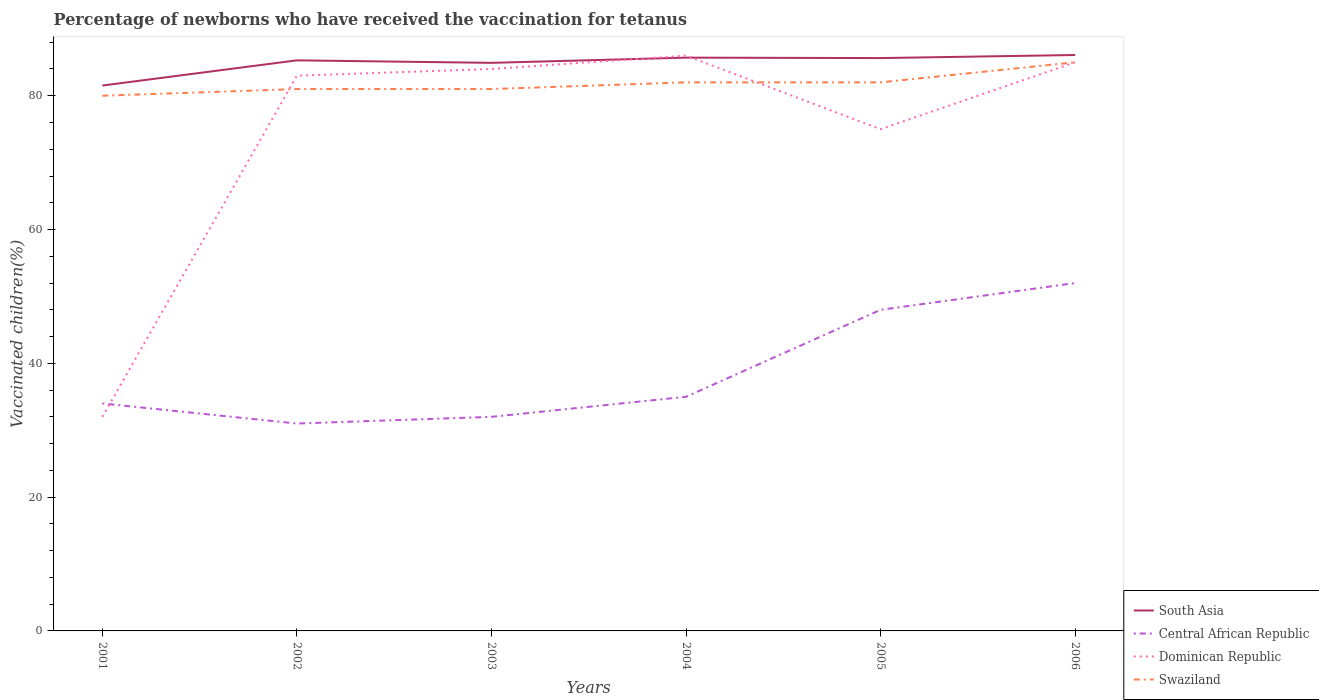How many different coloured lines are there?
Your response must be concise. 4. Does the line corresponding to South Asia intersect with the line corresponding to Dominican Republic?
Your answer should be compact. Yes. Across all years, what is the maximum percentage of vaccinated children in Dominican Republic?
Provide a succinct answer. 32. What is the total percentage of vaccinated children in Dominican Republic in the graph?
Offer a terse response. -53. What is the difference between the highest and the second highest percentage of vaccinated children in South Asia?
Ensure brevity in your answer.  4.57. Are the values on the major ticks of Y-axis written in scientific E-notation?
Your answer should be very brief. No. Where does the legend appear in the graph?
Keep it short and to the point. Bottom right. How many legend labels are there?
Give a very brief answer. 4. What is the title of the graph?
Provide a short and direct response. Percentage of newborns who have received the vaccination for tetanus. What is the label or title of the Y-axis?
Your response must be concise. Vaccinated children(%). What is the Vaccinated children(%) of South Asia in 2001?
Your answer should be compact. 81.52. What is the Vaccinated children(%) in Central African Republic in 2001?
Provide a succinct answer. 34. What is the Vaccinated children(%) of Dominican Republic in 2001?
Make the answer very short. 32. What is the Vaccinated children(%) of Swaziland in 2001?
Offer a terse response. 80. What is the Vaccinated children(%) of South Asia in 2002?
Offer a terse response. 85.29. What is the Vaccinated children(%) of Swaziland in 2002?
Provide a succinct answer. 81. What is the Vaccinated children(%) in South Asia in 2003?
Provide a short and direct response. 84.92. What is the Vaccinated children(%) in Central African Republic in 2003?
Make the answer very short. 32. What is the Vaccinated children(%) of Dominican Republic in 2003?
Your answer should be compact. 84. What is the Vaccinated children(%) in Swaziland in 2003?
Your answer should be very brief. 81. What is the Vaccinated children(%) of South Asia in 2004?
Make the answer very short. 85.7. What is the Vaccinated children(%) of Central African Republic in 2004?
Offer a very short reply. 35. What is the Vaccinated children(%) of Dominican Republic in 2004?
Provide a short and direct response. 86. What is the Vaccinated children(%) of South Asia in 2005?
Ensure brevity in your answer.  85.63. What is the Vaccinated children(%) in Dominican Republic in 2005?
Your answer should be compact. 75. What is the Vaccinated children(%) of Swaziland in 2005?
Your response must be concise. 82. What is the Vaccinated children(%) in South Asia in 2006?
Your answer should be compact. 86.09. What is the Vaccinated children(%) in Central African Republic in 2006?
Provide a succinct answer. 52. Across all years, what is the maximum Vaccinated children(%) of South Asia?
Keep it short and to the point. 86.09. Across all years, what is the minimum Vaccinated children(%) of South Asia?
Give a very brief answer. 81.52. Across all years, what is the minimum Vaccinated children(%) of Central African Republic?
Ensure brevity in your answer.  31. Across all years, what is the minimum Vaccinated children(%) in Dominican Republic?
Your response must be concise. 32. Across all years, what is the minimum Vaccinated children(%) in Swaziland?
Provide a succinct answer. 80. What is the total Vaccinated children(%) of South Asia in the graph?
Your answer should be very brief. 509.15. What is the total Vaccinated children(%) in Central African Republic in the graph?
Your answer should be compact. 232. What is the total Vaccinated children(%) of Dominican Republic in the graph?
Provide a short and direct response. 445. What is the total Vaccinated children(%) of Swaziland in the graph?
Provide a succinct answer. 491. What is the difference between the Vaccinated children(%) in South Asia in 2001 and that in 2002?
Your answer should be compact. -3.77. What is the difference between the Vaccinated children(%) in Dominican Republic in 2001 and that in 2002?
Your answer should be very brief. -51. What is the difference between the Vaccinated children(%) of Swaziland in 2001 and that in 2002?
Keep it short and to the point. -1. What is the difference between the Vaccinated children(%) in South Asia in 2001 and that in 2003?
Ensure brevity in your answer.  -3.39. What is the difference between the Vaccinated children(%) of Dominican Republic in 2001 and that in 2003?
Offer a very short reply. -52. What is the difference between the Vaccinated children(%) in South Asia in 2001 and that in 2004?
Your response must be concise. -4.17. What is the difference between the Vaccinated children(%) in Dominican Republic in 2001 and that in 2004?
Offer a very short reply. -54. What is the difference between the Vaccinated children(%) of South Asia in 2001 and that in 2005?
Provide a succinct answer. -4.11. What is the difference between the Vaccinated children(%) in Dominican Republic in 2001 and that in 2005?
Provide a succinct answer. -43. What is the difference between the Vaccinated children(%) in South Asia in 2001 and that in 2006?
Give a very brief answer. -4.57. What is the difference between the Vaccinated children(%) in Dominican Republic in 2001 and that in 2006?
Give a very brief answer. -53. What is the difference between the Vaccinated children(%) of South Asia in 2002 and that in 2003?
Your answer should be compact. 0.37. What is the difference between the Vaccinated children(%) in Central African Republic in 2002 and that in 2003?
Offer a very short reply. -1. What is the difference between the Vaccinated children(%) in Swaziland in 2002 and that in 2003?
Your answer should be very brief. 0. What is the difference between the Vaccinated children(%) in South Asia in 2002 and that in 2004?
Provide a short and direct response. -0.4. What is the difference between the Vaccinated children(%) in Swaziland in 2002 and that in 2004?
Provide a succinct answer. -1. What is the difference between the Vaccinated children(%) in South Asia in 2002 and that in 2005?
Provide a succinct answer. -0.34. What is the difference between the Vaccinated children(%) of Central African Republic in 2002 and that in 2005?
Provide a succinct answer. -17. What is the difference between the Vaccinated children(%) of Swaziland in 2002 and that in 2005?
Ensure brevity in your answer.  -1. What is the difference between the Vaccinated children(%) of South Asia in 2002 and that in 2006?
Ensure brevity in your answer.  -0.8. What is the difference between the Vaccinated children(%) in Dominican Republic in 2002 and that in 2006?
Give a very brief answer. -2. What is the difference between the Vaccinated children(%) in Swaziland in 2002 and that in 2006?
Offer a terse response. -4. What is the difference between the Vaccinated children(%) in South Asia in 2003 and that in 2004?
Keep it short and to the point. -0.78. What is the difference between the Vaccinated children(%) of South Asia in 2003 and that in 2005?
Offer a terse response. -0.71. What is the difference between the Vaccinated children(%) of Central African Republic in 2003 and that in 2005?
Provide a succinct answer. -16. What is the difference between the Vaccinated children(%) in Dominican Republic in 2003 and that in 2005?
Keep it short and to the point. 9. What is the difference between the Vaccinated children(%) of Swaziland in 2003 and that in 2005?
Provide a succinct answer. -1. What is the difference between the Vaccinated children(%) of South Asia in 2003 and that in 2006?
Provide a short and direct response. -1.17. What is the difference between the Vaccinated children(%) of Central African Republic in 2003 and that in 2006?
Offer a terse response. -20. What is the difference between the Vaccinated children(%) of Dominican Republic in 2003 and that in 2006?
Offer a very short reply. -1. What is the difference between the Vaccinated children(%) of Swaziland in 2003 and that in 2006?
Provide a succinct answer. -4. What is the difference between the Vaccinated children(%) of South Asia in 2004 and that in 2005?
Provide a succinct answer. 0.07. What is the difference between the Vaccinated children(%) in Central African Republic in 2004 and that in 2005?
Your answer should be very brief. -13. What is the difference between the Vaccinated children(%) of Dominican Republic in 2004 and that in 2005?
Offer a terse response. 11. What is the difference between the Vaccinated children(%) of Swaziland in 2004 and that in 2005?
Your answer should be compact. 0. What is the difference between the Vaccinated children(%) in South Asia in 2004 and that in 2006?
Provide a succinct answer. -0.39. What is the difference between the Vaccinated children(%) of Dominican Republic in 2004 and that in 2006?
Your response must be concise. 1. What is the difference between the Vaccinated children(%) in South Asia in 2005 and that in 2006?
Offer a very short reply. -0.46. What is the difference between the Vaccinated children(%) in Central African Republic in 2005 and that in 2006?
Give a very brief answer. -4. What is the difference between the Vaccinated children(%) of Dominican Republic in 2005 and that in 2006?
Provide a short and direct response. -10. What is the difference between the Vaccinated children(%) of Swaziland in 2005 and that in 2006?
Give a very brief answer. -3. What is the difference between the Vaccinated children(%) in South Asia in 2001 and the Vaccinated children(%) in Central African Republic in 2002?
Give a very brief answer. 50.52. What is the difference between the Vaccinated children(%) in South Asia in 2001 and the Vaccinated children(%) in Dominican Republic in 2002?
Provide a short and direct response. -1.48. What is the difference between the Vaccinated children(%) in South Asia in 2001 and the Vaccinated children(%) in Swaziland in 2002?
Offer a terse response. 0.52. What is the difference between the Vaccinated children(%) of Central African Republic in 2001 and the Vaccinated children(%) of Dominican Republic in 2002?
Provide a short and direct response. -49. What is the difference between the Vaccinated children(%) of Central African Republic in 2001 and the Vaccinated children(%) of Swaziland in 2002?
Make the answer very short. -47. What is the difference between the Vaccinated children(%) of Dominican Republic in 2001 and the Vaccinated children(%) of Swaziland in 2002?
Give a very brief answer. -49. What is the difference between the Vaccinated children(%) of South Asia in 2001 and the Vaccinated children(%) of Central African Republic in 2003?
Make the answer very short. 49.52. What is the difference between the Vaccinated children(%) in South Asia in 2001 and the Vaccinated children(%) in Dominican Republic in 2003?
Ensure brevity in your answer.  -2.48. What is the difference between the Vaccinated children(%) of South Asia in 2001 and the Vaccinated children(%) of Swaziland in 2003?
Make the answer very short. 0.52. What is the difference between the Vaccinated children(%) in Central African Republic in 2001 and the Vaccinated children(%) in Dominican Republic in 2003?
Offer a terse response. -50. What is the difference between the Vaccinated children(%) of Central African Republic in 2001 and the Vaccinated children(%) of Swaziland in 2003?
Offer a terse response. -47. What is the difference between the Vaccinated children(%) in Dominican Republic in 2001 and the Vaccinated children(%) in Swaziland in 2003?
Offer a very short reply. -49. What is the difference between the Vaccinated children(%) of South Asia in 2001 and the Vaccinated children(%) of Central African Republic in 2004?
Keep it short and to the point. 46.52. What is the difference between the Vaccinated children(%) in South Asia in 2001 and the Vaccinated children(%) in Dominican Republic in 2004?
Make the answer very short. -4.48. What is the difference between the Vaccinated children(%) of South Asia in 2001 and the Vaccinated children(%) of Swaziland in 2004?
Keep it short and to the point. -0.48. What is the difference between the Vaccinated children(%) in Central African Republic in 2001 and the Vaccinated children(%) in Dominican Republic in 2004?
Keep it short and to the point. -52. What is the difference between the Vaccinated children(%) in Central African Republic in 2001 and the Vaccinated children(%) in Swaziland in 2004?
Give a very brief answer. -48. What is the difference between the Vaccinated children(%) of South Asia in 2001 and the Vaccinated children(%) of Central African Republic in 2005?
Give a very brief answer. 33.52. What is the difference between the Vaccinated children(%) of South Asia in 2001 and the Vaccinated children(%) of Dominican Republic in 2005?
Your response must be concise. 6.52. What is the difference between the Vaccinated children(%) in South Asia in 2001 and the Vaccinated children(%) in Swaziland in 2005?
Provide a succinct answer. -0.48. What is the difference between the Vaccinated children(%) in Central African Republic in 2001 and the Vaccinated children(%) in Dominican Republic in 2005?
Keep it short and to the point. -41. What is the difference between the Vaccinated children(%) in Central African Republic in 2001 and the Vaccinated children(%) in Swaziland in 2005?
Offer a terse response. -48. What is the difference between the Vaccinated children(%) in Dominican Republic in 2001 and the Vaccinated children(%) in Swaziland in 2005?
Offer a very short reply. -50. What is the difference between the Vaccinated children(%) of South Asia in 2001 and the Vaccinated children(%) of Central African Republic in 2006?
Ensure brevity in your answer.  29.52. What is the difference between the Vaccinated children(%) of South Asia in 2001 and the Vaccinated children(%) of Dominican Republic in 2006?
Ensure brevity in your answer.  -3.48. What is the difference between the Vaccinated children(%) of South Asia in 2001 and the Vaccinated children(%) of Swaziland in 2006?
Offer a terse response. -3.48. What is the difference between the Vaccinated children(%) of Central African Republic in 2001 and the Vaccinated children(%) of Dominican Republic in 2006?
Give a very brief answer. -51. What is the difference between the Vaccinated children(%) in Central African Republic in 2001 and the Vaccinated children(%) in Swaziland in 2006?
Your answer should be compact. -51. What is the difference between the Vaccinated children(%) in Dominican Republic in 2001 and the Vaccinated children(%) in Swaziland in 2006?
Provide a short and direct response. -53. What is the difference between the Vaccinated children(%) in South Asia in 2002 and the Vaccinated children(%) in Central African Republic in 2003?
Provide a short and direct response. 53.29. What is the difference between the Vaccinated children(%) of South Asia in 2002 and the Vaccinated children(%) of Dominican Republic in 2003?
Provide a succinct answer. 1.29. What is the difference between the Vaccinated children(%) of South Asia in 2002 and the Vaccinated children(%) of Swaziland in 2003?
Offer a terse response. 4.29. What is the difference between the Vaccinated children(%) of Central African Republic in 2002 and the Vaccinated children(%) of Dominican Republic in 2003?
Make the answer very short. -53. What is the difference between the Vaccinated children(%) in South Asia in 2002 and the Vaccinated children(%) in Central African Republic in 2004?
Your answer should be compact. 50.29. What is the difference between the Vaccinated children(%) in South Asia in 2002 and the Vaccinated children(%) in Dominican Republic in 2004?
Provide a succinct answer. -0.71. What is the difference between the Vaccinated children(%) in South Asia in 2002 and the Vaccinated children(%) in Swaziland in 2004?
Give a very brief answer. 3.29. What is the difference between the Vaccinated children(%) in Central African Republic in 2002 and the Vaccinated children(%) in Dominican Republic in 2004?
Provide a short and direct response. -55. What is the difference between the Vaccinated children(%) in Central African Republic in 2002 and the Vaccinated children(%) in Swaziland in 2004?
Provide a succinct answer. -51. What is the difference between the Vaccinated children(%) of South Asia in 2002 and the Vaccinated children(%) of Central African Republic in 2005?
Offer a terse response. 37.29. What is the difference between the Vaccinated children(%) in South Asia in 2002 and the Vaccinated children(%) in Dominican Republic in 2005?
Keep it short and to the point. 10.29. What is the difference between the Vaccinated children(%) of South Asia in 2002 and the Vaccinated children(%) of Swaziland in 2005?
Give a very brief answer. 3.29. What is the difference between the Vaccinated children(%) of Central African Republic in 2002 and the Vaccinated children(%) of Dominican Republic in 2005?
Provide a short and direct response. -44. What is the difference between the Vaccinated children(%) of Central African Republic in 2002 and the Vaccinated children(%) of Swaziland in 2005?
Provide a succinct answer. -51. What is the difference between the Vaccinated children(%) of Dominican Republic in 2002 and the Vaccinated children(%) of Swaziland in 2005?
Offer a terse response. 1. What is the difference between the Vaccinated children(%) of South Asia in 2002 and the Vaccinated children(%) of Central African Republic in 2006?
Your answer should be very brief. 33.29. What is the difference between the Vaccinated children(%) of South Asia in 2002 and the Vaccinated children(%) of Dominican Republic in 2006?
Provide a short and direct response. 0.29. What is the difference between the Vaccinated children(%) in South Asia in 2002 and the Vaccinated children(%) in Swaziland in 2006?
Offer a terse response. 0.29. What is the difference between the Vaccinated children(%) in Central African Republic in 2002 and the Vaccinated children(%) in Dominican Republic in 2006?
Offer a very short reply. -54. What is the difference between the Vaccinated children(%) in Central African Republic in 2002 and the Vaccinated children(%) in Swaziland in 2006?
Offer a terse response. -54. What is the difference between the Vaccinated children(%) of South Asia in 2003 and the Vaccinated children(%) of Central African Republic in 2004?
Keep it short and to the point. 49.92. What is the difference between the Vaccinated children(%) of South Asia in 2003 and the Vaccinated children(%) of Dominican Republic in 2004?
Ensure brevity in your answer.  -1.08. What is the difference between the Vaccinated children(%) of South Asia in 2003 and the Vaccinated children(%) of Swaziland in 2004?
Offer a terse response. 2.92. What is the difference between the Vaccinated children(%) in Central African Republic in 2003 and the Vaccinated children(%) in Dominican Republic in 2004?
Offer a terse response. -54. What is the difference between the Vaccinated children(%) of South Asia in 2003 and the Vaccinated children(%) of Central African Republic in 2005?
Offer a very short reply. 36.92. What is the difference between the Vaccinated children(%) in South Asia in 2003 and the Vaccinated children(%) in Dominican Republic in 2005?
Keep it short and to the point. 9.92. What is the difference between the Vaccinated children(%) in South Asia in 2003 and the Vaccinated children(%) in Swaziland in 2005?
Your response must be concise. 2.92. What is the difference between the Vaccinated children(%) of Central African Republic in 2003 and the Vaccinated children(%) of Dominican Republic in 2005?
Make the answer very short. -43. What is the difference between the Vaccinated children(%) of Dominican Republic in 2003 and the Vaccinated children(%) of Swaziland in 2005?
Keep it short and to the point. 2. What is the difference between the Vaccinated children(%) of South Asia in 2003 and the Vaccinated children(%) of Central African Republic in 2006?
Make the answer very short. 32.92. What is the difference between the Vaccinated children(%) in South Asia in 2003 and the Vaccinated children(%) in Dominican Republic in 2006?
Your response must be concise. -0.08. What is the difference between the Vaccinated children(%) of South Asia in 2003 and the Vaccinated children(%) of Swaziland in 2006?
Your answer should be very brief. -0.08. What is the difference between the Vaccinated children(%) in Central African Republic in 2003 and the Vaccinated children(%) in Dominican Republic in 2006?
Provide a short and direct response. -53. What is the difference between the Vaccinated children(%) in Central African Republic in 2003 and the Vaccinated children(%) in Swaziland in 2006?
Offer a terse response. -53. What is the difference between the Vaccinated children(%) in South Asia in 2004 and the Vaccinated children(%) in Central African Republic in 2005?
Your response must be concise. 37.7. What is the difference between the Vaccinated children(%) of South Asia in 2004 and the Vaccinated children(%) of Dominican Republic in 2005?
Ensure brevity in your answer.  10.7. What is the difference between the Vaccinated children(%) in South Asia in 2004 and the Vaccinated children(%) in Swaziland in 2005?
Your answer should be compact. 3.7. What is the difference between the Vaccinated children(%) of Central African Republic in 2004 and the Vaccinated children(%) of Dominican Republic in 2005?
Provide a succinct answer. -40. What is the difference between the Vaccinated children(%) in Central African Republic in 2004 and the Vaccinated children(%) in Swaziland in 2005?
Provide a succinct answer. -47. What is the difference between the Vaccinated children(%) in South Asia in 2004 and the Vaccinated children(%) in Central African Republic in 2006?
Your answer should be compact. 33.7. What is the difference between the Vaccinated children(%) in South Asia in 2004 and the Vaccinated children(%) in Dominican Republic in 2006?
Your answer should be compact. 0.7. What is the difference between the Vaccinated children(%) of South Asia in 2004 and the Vaccinated children(%) of Swaziland in 2006?
Provide a succinct answer. 0.7. What is the difference between the Vaccinated children(%) in Central African Republic in 2004 and the Vaccinated children(%) in Dominican Republic in 2006?
Make the answer very short. -50. What is the difference between the Vaccinated children(%) in Dominican Republic in 2004 and the Vaccinated children(%) in Swaziland in 2006?
Give a very brief answer. 1. What is the difference between the Vaccinated children(%) in South Asia in 2005 and the Vaccinated children(%) in Central African Republic in 2006?
Provide a succinct answer. 33.63. What is the difference between the Vaccinated children(%) of South Asia in 2005 and the Vaccinated children(%) of Dominican Republic in 2006?
Your answer should be compact. 0.63. What is the difference between the Vaccinated children(%) of South Asia in 2005 and the Vaccinated children(%) of Swaziland in 2006?
Offer a terse response. 0.63. What is the difference between the Vaccinated children(%) of Central African Republic in 2005 and the Vaccinated children(%) of Dominican Republic in 2006?
Your response must be concise. -37. What is the difference between the Vaccinated children(%) in Central African Republic in 2005 and the Vaccinated children(%) in Swaziland in 2006?
Provide a succinct answer. -37. What is the average Vaccinated children(%) in South Asia per year?
Your answer should be very brief. 84.86. What is the average Vaccinated children(%) of Central African Republic per year?
Provide a short and direct response. 38.67. What is the average Vaccinated children(%) in Dominican Republic per year?
Provide a short and direct response. 74.17. What is the average Vaccinated children(%) in Swaziland per year?
Give a very brief answer. 81.83. In the year 2001, what is the difference between the Vaccinated children(%) of South Asia and Vaccinated children(%) of Central African Republic?
Ensure brevity in your answer.  47.52. In the year 2001, what is the difference between the Vaccinated children(%) in South Asia and Vaccinated children(%) in Dominican Republic?
Offer a terse response. 49.52. In the year 2001, what is the difference between the Vaccinated children(%) of South Asia and Vaccinated children(%) of Swaziland?
Offer a terse response. 1.52. In the year 2001, what is the difference between the Vaccinated children(%) of Central African Republic and Vaccinated children(%) of Dominican Republic?
Offer a terse response. 2. In the year 2001, what is the difference between the Vaccinated children(%) in Central African Republic and Vaccinated children(%) in Swaziland?
Ensure brevity in your answer.  -46. In the year 2001, what is the difference between the Vaccinated children(%) of Dominican Republic and Vaccinated children(%) of Swaziland?
Offer a very short reply. -48. In the year 2002, what is the difference between the Vaccinated children(%) of South Asia and Vaccinated children(%) of Central African Republic?
Ensure brevity in your answer.  54.29. In the year 2002, what is the difference between the Vaccinated children(%) of South Asia and Vaccinated children(%) of Dominican Republic?
Your response must be concise. 2.29. In the year 2002, what is the difference between the Vaccinated children(%) of South Asia and Vaccinated children(%) of Swaziland?
Your response must be concise. 4.29. In the year 2002, what is the difference between the Vaccinated children(%) in Central African Republic and Vaccinated children(%) in Dominican Republic?
Your answer should be compact. -52. In the year 2002, what is the difference between the Vaccinated children(%) in Central African Republic and Vaccinated children(%) in Swaziland?
Your answer should be very brief. -50. In the year 2003, what is the difference between the Vaccinated children(%) of South Asia and Vaccinated children(%) of Central African Republic?
Keep it short and to the point. 52.92. In the year 2003, what is the difference between the Vaccinated children(%) in South Asia and Vaccinated children(%) in Dominican Republic?
Your answer should be very brief. 0.92. In the year 2003, what is the difference between the Vaccinated children(%) in South Asia and Vaccinated children(%) in Swaziland?
Keep it short and to the point. 3.92. In the year 2003, what is the difference between the Vaccinated children(%) of Central African Republic and Vaccinated children(%) of Dominican Republic?
Your answer should be very brief. -52. In the year 2003, what is the difference between the Vaccinated children(%) in Central African Republic and Vaccinated children(%) in Swaziland?
Your response must be concise. -49. In the year 2003, what is the difference between the Vaccinated children(%) in Dominican Republic and Vaccinated children(%) in Swaziland?
Offer a terse response. 3. In the year 2004, what is the difference between the Vaccinated children(%) of South Asia and Vaccinated children(%) of Central African Republic?
Give a very brief answer. 50.7. In the year 2004, what is the difference between the Vaccinated children(%) of South Asia and Vaccinated children(%) of Dominican Republic?
Your answer should be compact. -0.3. In the year 2004, what is the difference between the Vaccinated children(%) in South Asia and Vaccinated children(%) in Swaziland?
Give a very brief answer. 3.7. In the year 2004, what is the difference between the Vaccinated children(%) in Central African Republic and Vaccinated children(%) in Dominican Republic?
Make the answer very short. -51. In the year 2004, what is the difference between the Vaccinated children(%) of Central African Republic and Vaccinated children(%) of Swaziland?
Ensure brevity in your answer.  -47. In the year 2005, what is the difference between the Vaccinated children(%) of South Asia and Vaccinated children(%) of Central African Republic?
Make the answer very short. 37.63. In the year 2005, what is the difference between the Vaccinated children(%) in South Asia and Vaccinated children(%) in Dominican Republic?
Offer a terse response. 10.63. In the year 2005, what is the difference between the Vaccinated children(%) of South Asia and Vaccinated children(%) of Swaziland?
Give a very brief answer. 3.63. In the year 2005, what is the difference between the Vaccinated children(%) in Central African Republic and Vaccinated children(%) in Swaziland?
Provide a succinct answer. -34. In the year 2005, what is the difference between the Vaccinated children(%) of Dominican Republic and Vaccinated children(%) of Swaziland?
Offer a terse response. -7. In the year 2006, what is the difference between the Vaccinated children(%) in South Asia and Vaccinated children(%) in Central African Republic?
Provide a succinct answer. 34.09. In the year 2006, what is the difference between the Vaccinated children(%) in South Asia and Vaccinated children(%) in Dominican Republic?
Your answer should be compact. 1.09. In the year 2006, what is the difference between the Vaccinated children(%) of South Asia and Vaccinated children(%) of Swaziland?
Your response must be concise. 1.09. In the year 2006, what is the difference between the Vaccinated children(%) of Central African Republic and Vaccinated children(%) of Dominican Republic?
Provide a succinct answer. -33. In the year 2006, what is the difference between the Vaccinated children(%) in Central African Republic and Vaccinated children(%) in Swaziland?
Your answer should be compact. -33. What is the ratio of the Vaccinated children(%) in South Asia in 2001 to that in 2002?
Ensure brevity in your answer.  0.96. What is the ratio of the Vaccinated children(%) of Central African Republic in 2001 to that in 2002?
Your answer should be very brief. 1.1. What is the ratio of the Vaccinated children(%) in Dominican Republic in 2001 to that in 2002?
Provide a short and direct response. 0.39. What is the ratio of the Vaccinated children(%) of Dominican Republic in 2001 to that in 2003?
Offer a terse response. 0.38. What is the ratio of the Vaccinated children(%) of Swaziland in 2001 to that in 2003?
Make the answer very short. 0.99. What is the ratio of the Vaccinated children(%) of South Asia in 2001 to that in 2004?
Give a very brief answer. 0.95. What is the ratio of the Vaccinated children(%) in Central African Republic in 2001 to that in 2004?
Offer a very short reply. 0.97. What is the ratio of the Vaccinated children(%) of Dominican Republic in 2001 to that in 2004?
Provide a short and direct response. 0.37. What is the ratio of the Vaccinated children(%) in Swaziland in 2001 to that in 2004?
Give a very brief answer. 0.98. What is the ratio of the Vaccinated children(%) of South Asia in 2001 to that in 2005?
Your response must be concise. 0.95. What is the ratio of the Vaccinated children(%) in Central African Republic in 2001 to that in 2005?
Offer a very short reply. 0.71. What is the ratio of the Vaccinated children(%) in Dominican Republic in 2001 to that in 2005?
Offer a terse response. 0.43. What is the ratio of the Vaccinated children(%) of Swaziland in 2001 to that in 2005?
Your answer should be compact. 0.98. What is the ratio of the Vaccinated children(%) in South Asia in 2001 to that in 2006?
Give a very brief answer. 0.95. What is the ratio of the Vaccinated children(%) of Central African Republic in 2001 to that in 2006?
Your answer should be compact. 0.65. What is the ratio of the Vaccinated children(%) in Dominican Republic in 2001 to that in 2006?
Give a very brief answer. 0.38. What is the ratio of the Vaccinated children(%) of Swaziland in 2001 to that in 2006?
Provide a short and direct response. 0.94. What is the ratio of the Vaccinated children(%) of Central African Republic in 2002 to that in 2003?
Ensure brevity in your answer.  0.97. What is the ratio of the Vaccinated children(%) in Dominican Republic in 2002 to that in 2003?
Offer a terse response. 0.99. What is the ratio of the Vaccinated children(%) of South Asia in 2002 to that in 2004?
Your answer should be very brief. 1. What is the ratio of the Vaccinated children(%) of Central African Republic in 2002 to that in 2004?
Keep it short and to the point. 0.89. What is the ratio of the Vaccinated children(%) in Dominican Republic in 2002 to that in 2004?
Give a very brief answer. 0.97. What is the ratio of the Vaccinated children(%) in Swaziland in 2002 to that in 2004?
Give a very brief answer. 0.99. What is the ratio of the Vaccinated children(%) in South Asia in 2002 to that in 2005?
Your answer should be compact. 1. What is the ratio of the Vaccinated children(%) of Central African Republic in 2002 to that in 2005?
Your response must be concise. 0.65. What is the ratio of the Vaccinated children(%) of Dominican Republic in 2002 to that in 2005?
Offer a very short reply. 1.11. What is the ratio of the Vaccinated children(%) in South Asia in 2002 to that in 2006?
Offer a very short reply. 0.99. What is the ratio of the Vaccinated children(%) in Central African Republic in 2002 to that in 2006?
Your answer should be very brief. 0.6. What is the ratio of the Vaccinated children(%) in Dominican Republic in 2002 to that in 2006?
Provide a short and direct response. 0.98. What is the ratio of the Vaccinated children(%) of Swaziland in 2002 to that in 2006?
Your answer should be compact. 0.95. What is the ratio of the Vaccinated children(%) of South Asia in 2003 to that in 2004?
Provide a succinct answer. 0.99. What is the ratio of the Vaccinated children(%) of Central African Republic in 2003 to that in 2004?
Your response must be concise. 0.91. What is the ratio of the Vaccinated children(%) in Dominican Republic in 2003 to that in 2004?
Offer a terse response. 0.98. What is the ratio of the Vaccinated children(%) of South Asia in 2003 to that in 2005?
Keep it short and to the point. 0.99. What is the ratio of the Vaccinated children(%) in Dominican Republic in 2003 to that in 2005?
Make the answer very short. 1.12. What is the ratio of the Vaccinated children(%) in Swaziland in 2003 to that in 2005?
Your answer should be compact. 0.99. What is the ratio of the Vaccinated children(%) of South Asia in 2003 to that in 2006?
Make the answer very short. 0.99. What is the ratio of the Vaccinated children(%) in Central African Republic in 2003 to that in 2006?
Ensure brevity in your answer.  0.62. What is the ratio of the Vaccinated children(%) of Swaziland in 2003 to that in 2006?
Your answer should be compact. 0.95. What is the ratio of the Vaccinated children(%) in South Asia in 2004 to that in 2005?
Offer a terse response. 1. What is the ratio of the Vaccinated children(%) of Central African Republic in 2004 to that in 2005?
Your answer should be very brief. 0.73. What is the ratio of the Vaccinated children(%) in Dominican Republic in 2004 to that in 2005?
Your answer should be very brief. 1.15. What is the ratio of the Vaccinated children(%) of South Asia in 2004 to that in 2006?
Offer a very short reply. 1. What is the ratio of the Vaccinated children(%) of Central African Republic in 2004 to that in 2006?
Provide a succinct answer. 0.67. What is the ratio of the Vaccinated children(%) of Dominican Republic in 2004 to that in 2006?
Keep it short and to the point. 1.01. What is the ratio of the Vaccinated children(%) in Swaziland in 2004 to that in 2006?
Give a very brief answer. 0.96. What is the ratio of the Vaccinated children(%) in South Asia in 2005 to that in 2006?
Provide a succinct answer. 0.99. What is the ratio of the Vaccinated children(%) in Central African Republic in 2005 to that in 2006?
Offer a terse response. 0.92. What is the ratio of the Vaccinated children(%) of Dominican Republic in 2005 to that in 2006?
Offer a terse response. 0.88. What is the ratio of the Vaccinated children(%) in Swaziland in 2005 to that in 2006?
Offer a terse response. 0.96. What is the difference between the highest and the second highest Vaccinated children(%) of South Asia?
Give a very brief answer. 0.39. What is the difference between the highest and the second highest Vaccinated children(%) of Central African Republic?
Give a very brief answer. 4. What is the difference between the highest and the second highest Vaccinated children(%) of Dominican Republic?
Give a very brief answer. 1. What is the difference between the highest and the lowest Vaccinated children(%) in South Asia?
Your answer should be very brief. 4.57. What is the difference between the highest and the lowest Vaccinated children(%) in Dominican Republic?
Give a very brief answer. 54. What is the difference between the highest and the lowest Vaccinated children(%) of Swaziland?
Provide a short and direct response. 5. 